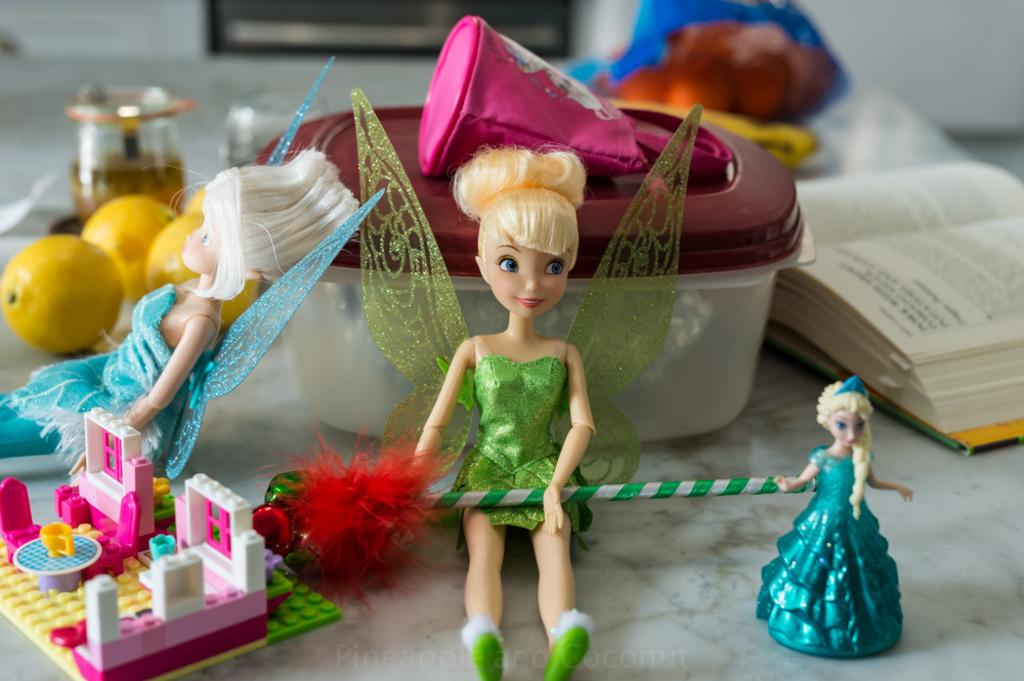What types of toys are on the table in the image? There are dolls and legos on the table in the image. What else can be found on the table besides toys? There are books and a box on the table. What type of twig is being used as a bookmark in the image? There is no twig present in the image, and no bookmark can be seen in the books. 